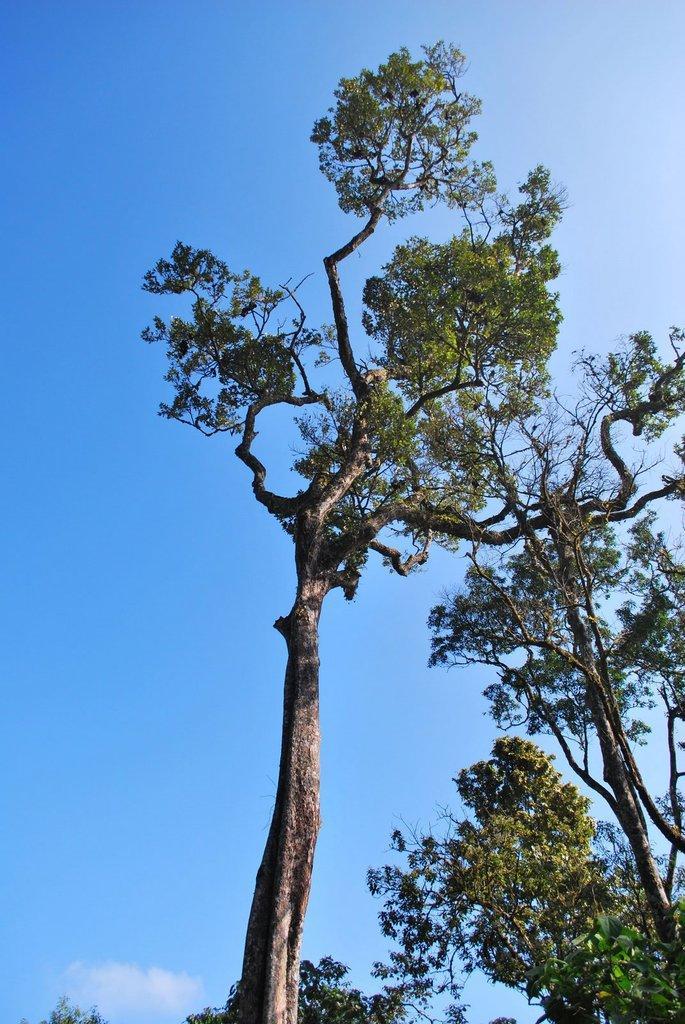Please provide a concise description of this image. In this picture I can see trees, and in the background there is sky. 